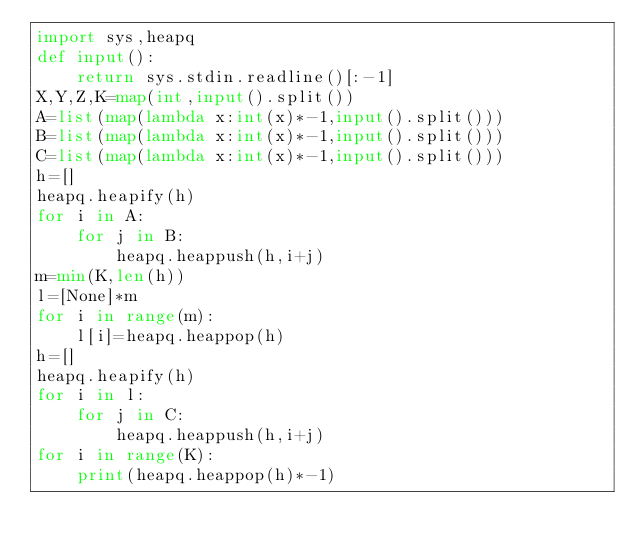<code> <loc_0><loc_0><loc_500><loc_500><_Python_>import sys,heapq
def input():
    return sys.stdin.readline()[:-1]
X,Y,Z,K=map(int,input().split())
A=list(map(lambda x:int(x)*-1,input().split()))
B=list(map(lambda x:int(x)*-1,input().split()))
C=list(map(lambda x:int(x)*-1,input().split()))
h=[]
heapq.heapify(h)
for i in A:
    for j in B:
        heapq.heappush(h,i+j)
m=min(K,len(h))
l=[None]*m
for i in range(m):
    l[i]=heapq.heappop(h)
h=[]
heapq.heapify(h)
for i in l:
    for j in C:
        heapq.heappush(h,i+j)
for i in range(K):
    print(heapq.heappop(h)*-1)</code> 